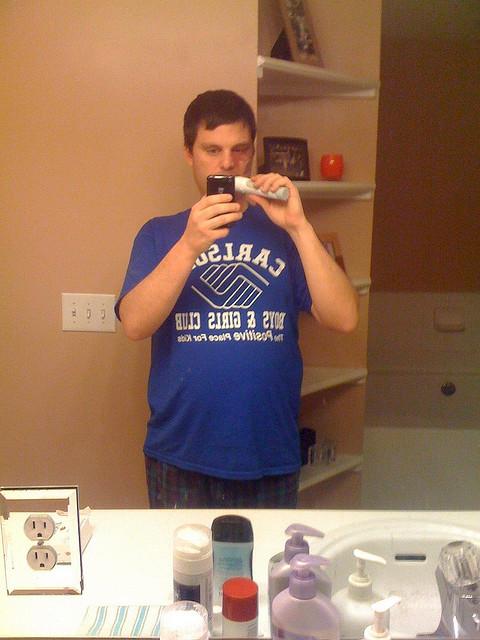What is the man in the picture holding in his right hand?
Short answer required. Phone. What room is this person in?
Short answer required. Bathroom. Who can belong to the club that is printed on the t-shirt?
Keep it brief. Boys and girls. What kind of pants is the man wearing?
Answer briefly. Jeans. 